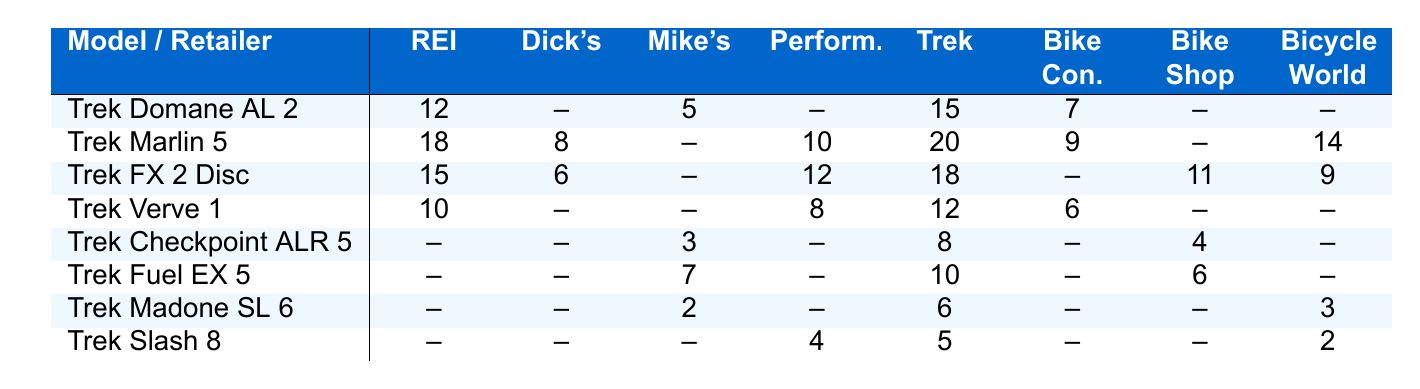What is the inventory level of the Trek FX 2 Disc at Dick's Sporting Goods? The table shows the inventory levels for each bicycle model at various retailers. For the Trek FX 2 Disc, the entry in the Dick's Sporting Goods column is 6.
Answer: 6 Which retailer has the highest inventory for the Trek Marlin 5? Reviewing the table, the inventories for the Trek Marlin 5 across different retailers are: REI (18), Dick's Sporting Goods (8), Performance Bicycle (10), Trek Bicycle Store (20), Bike Connection (9), and Bicycle World (14). The highest value is from the Trek Bicycle Store with 20.
Answer: Trek Bicycle Store How many Trek Domane AL 2 are available in total across all retailers? To find the total, we add up the available quantities: REI (12), Mike's Bikes (5), Trek Bicycle Store (15), and Bike Connection (7). So, total = 12 + 5 + 15 + 7 = 39.
Answer: 39 Is there any retailer that has stock for the Trek Madone SL 6? By checking the table, I find that Mike's Bikes has 2, Performance Bicycle has 6, and Bicycle World has 3 for the Trek Madone SL 6. Therefore, the answer is yes, there are multiple retailers.
Answer: Yes What is the average inventory of the Trek Verve 1 across all retailers? The Trek Verve 1 inventory is: REI (10), Performance Bicycle (8), Trek Bicycle Store (12), and Bike Connection (6). This gives us 10 + 8 + 12 + 6 = 36. The average is 36 / 4 = 9.
Answer: 9 How many models have no inventory listed at Bike Connection? The models with no inventory listed at Bike Connection are: Trek FX 2 Disc, Trek Checkpoint ALR 5, Trek Fuel EX 5, Trek Madone SL 6, and Trek Slash 8. There are a total of 5 models.
Answer: 5 What is the total inventory of Trek bicycles at the Performance Bicycle retailer? From the table, the inventories at Performance Bicycle are: Trek Marlin 5 (10), Trek FX 2 Disc (12), Trek Verve 1 (8), and Trek Slash 8 (4). Adding these up, we get 10 + 12 + 8 + 4 = 34.
Answer: 34 Which retailer shows no inventory for the Trek Slash 8? By examining the table, I can see that both REI and Mike's Bikes do not have any stock for the Trek Slash 8.
Answer: REI and Mike's Bikes What is the difference in inventory for the Trek Slash 8 between Performance Bicycle and Bicycle World? At Performance Bicycle, there are 4 Trek Slash 8 bicycles, while Bicycle World has 2. The difference is 4 - 2 = 2.
Answer: 2 How many more Trek FX 2 Disc bicycles are available at Trek Bicycle Store compared to Mike's Bikes? Checking the entries for Trek FX 2 Disc: Trek Bicycle Store has 18, and Mike's Bikes has none listed (0). The difference is 18 - 0 = 18.
Answer: 18 